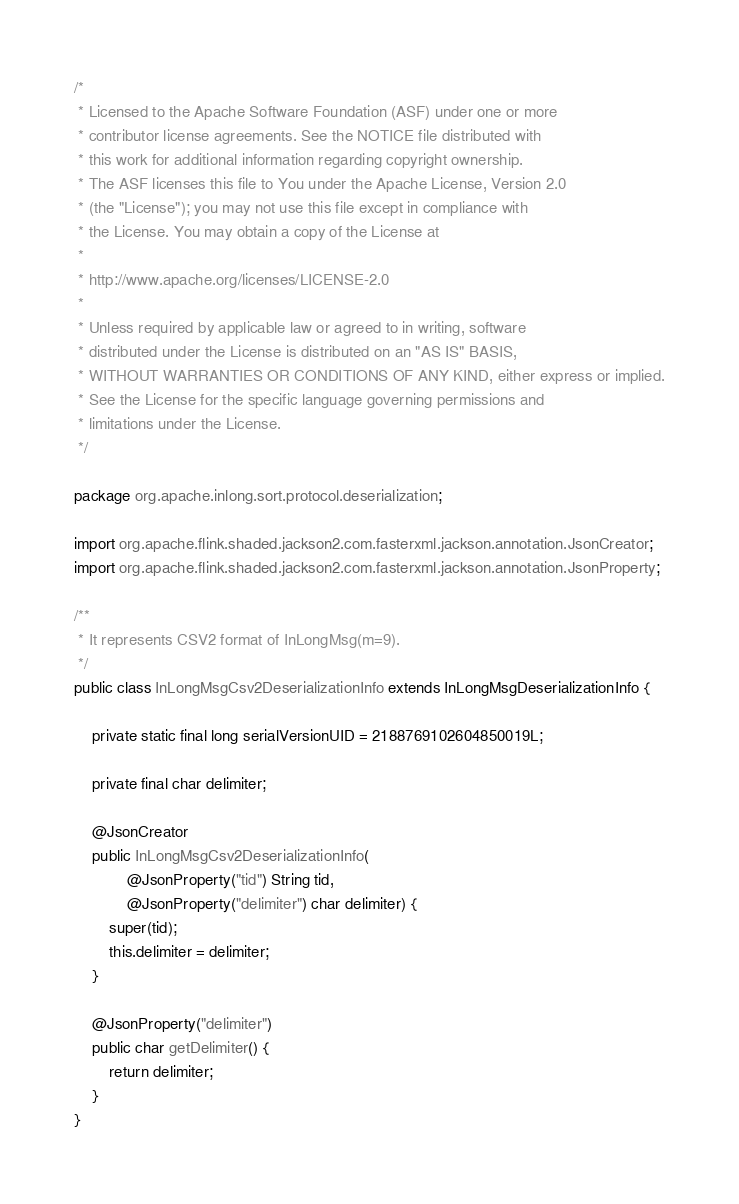<code> <loc_0><loc_0><loc_500><loc_500><_Java_>/*
 * Licensed to the Apache Software Foundation (ASF) under one or more
 * contributor license agreements. See the NOTICE file distributed with
 * this work for additional information regarding copyright ownership.
 * The ASF licenses this file to You under the Apache License, Version 2.0
 * (the "License"); you may not use this file except in compliance with
 * the License. You may obtain a copy of the License at
 *
 * http://www.apache.org/licenses/LICENSE-2.0
 *
 * Unless required by applicable law or agreed to in writing, software
 * distributed under the License is distributed on an "AS IS" BASIS,
 * WITHOUT WARRANTIES OR CONDITIONS OF ANY KIND, either express or implied.
 * See the License for the specific language governing permissions and
 * limitations under the License.
 */

package org.apache.inlong.sort.protocol.deserialization;

import org.apache.flink.shaded.jackson2.com.fasterxml.jackson.annotation.JsonCreator;
import org.apache.flink.shaded.jackson2.com.fasterxml.jackson.annotation.JsonProperty;

/**
 * It represents CSV2 format of InLongMsg(m=9).
 */
public class InLongMsgCsv2DeserializationInfo extends InLongMsgDeserializationInfo {

    private static final long serialVersionUID = 2188769102604850019L;

    private final char delimiter;

    @JsonCreator
    public InLongMsgCsv2DeserializationInfo(
            @JsonProperty("tid") String tid,
            @JsonProperty("delimiter") char delimiter) {
        super(tid);
        this.delimiter = delimiter;
    }

    @JsonProperty("delimiter")
    public char getDelimiter() {
        return delimiter;
    }
}
</code> 